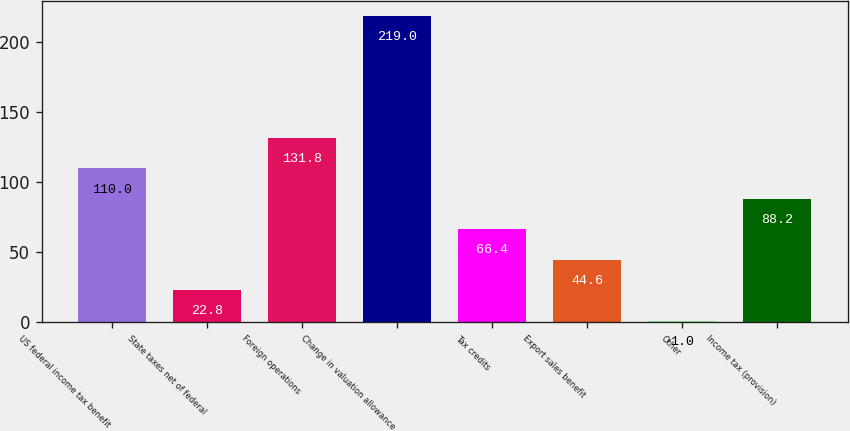Convert chart to OTSL. <chart><loc_0><loc_0><loc_500><loc_500><bar_chart><fcel>US federal income tax benefit<fcel>State taxes net of federal<fcel>Foreign operations<fcel>Change in valuation allowance<fcel>Tax credits<fcel>Export sales benefit<fcel>Other<fcel>Income tax (provision)<nl><fcel>110<fcel>22.8<fcel>131.8<fcel>219<fcel>66.4<fcel>44.6<fcel>1<fcel>88.2<nl></chart> 